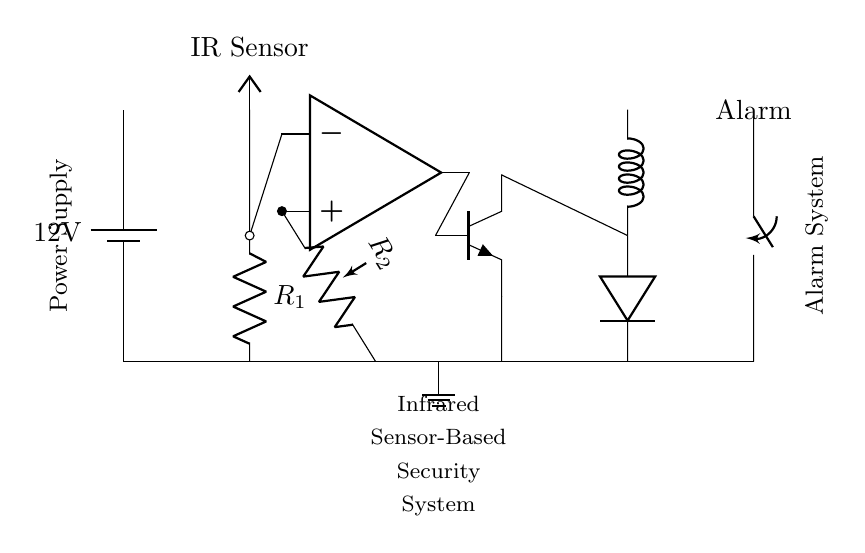what is the power supply voltage? The circuit uses a battery, labeled as 12V, which provides the required voltage for operation.
Answer: 12 volts what type of sensor is used in this circuit? The circuit diagram shows an infrared (IR) sensor, which is specifically designed to detect infrared light, typically used for motion detection and security applications.
Answer: Infrared sensor how does the alarm get activated? The alarm is connected to a relay controlled by a transistor, which is driven by the output of an operational amplifier. When the IR sensor detects motion, it allows current to activate the transistor, subsequently triggering the relay and turning the alarm on.
Answer: Via relay what is the role of the resistor labeled R1? Resistor R1 is typically used to limit the current flowing through the IR sensor, ensuring it operates safely within its specification while producing a valid output signal for detection.
Answer: Current limiting how many resistors are present in the circuit? There are two resistors, R1 and R2, shown in the circuit diagram, with R1 connected to the IR sensor and R2 connected to the non-inverting input of the operational amplifier.
Answer: Two resistors what happens to the transistor when the IR sensor detects motion? When motion is detected, the IR sensor output allows current to flow into the base of the transistor, turning it on. This allows current to pass from the collector to the emitter, completing the circuit to the relay and activating the alarm.
Answer: It turns on 